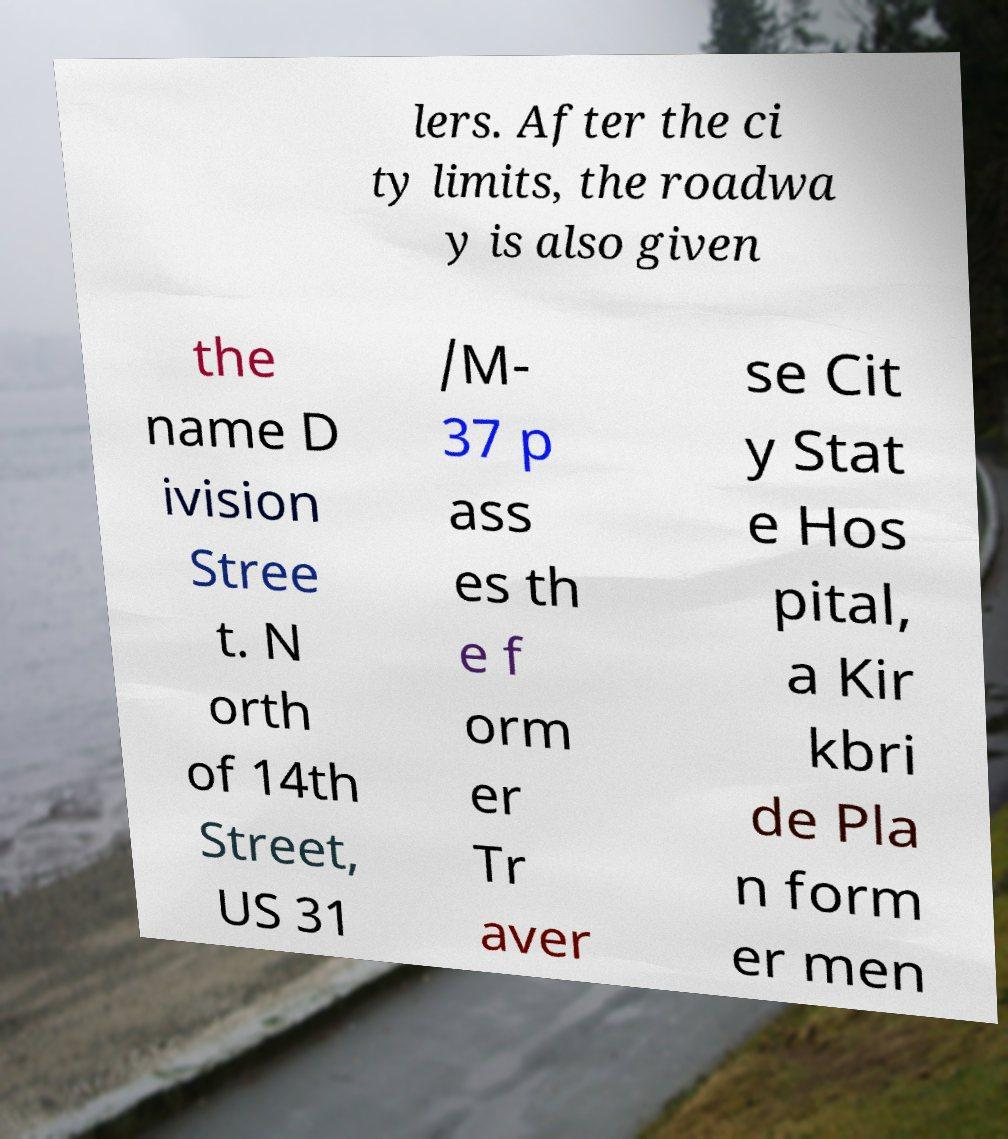What messages or text are displayed in this image? I need them in a readable, typed format. lers. After the ci ty limits, the roadwa y is also given the name D ivision Stree t. N orth of 14th Street, US 31 /M- 37 p ass es th e f orm er Tr aver se Cit y Stat e Hos pital, a Kir kbri de Pla n form er men 